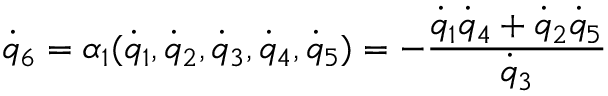<formula> <loc_0><loc_0><loc_500><loc_500>{ \dot { q } } _ { 6 } = \alpha _ { 1 } ( { \dot { q } } _ { 1 } , { \dot { q } } _ { 2 } , { \dot { q } } _ { 3 } , { \dot { q } } _ { 4 } , { \dot { q } } _ { 5 } ) = - \frac { { \dot { q } } _ { 1 } { \dot { q } } _ { 4 } + { \dot { q } } _ { 2 } { \dot { q } } _ { 5 } } { { \dot { q } } _ { 3 } }</formula> 